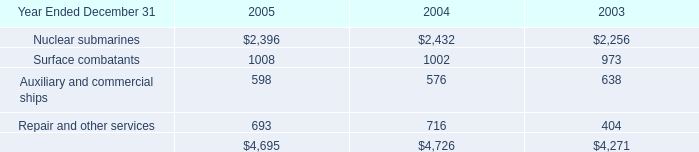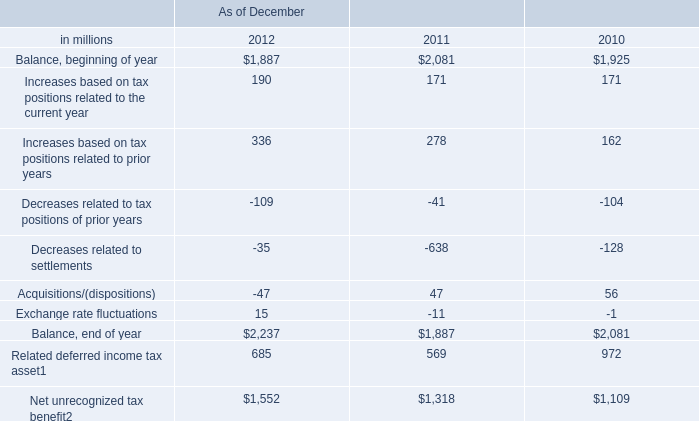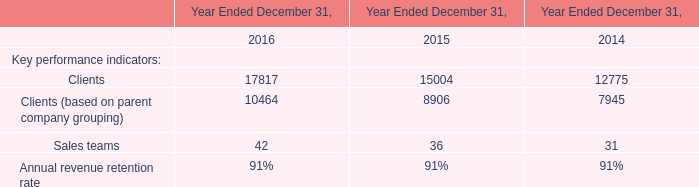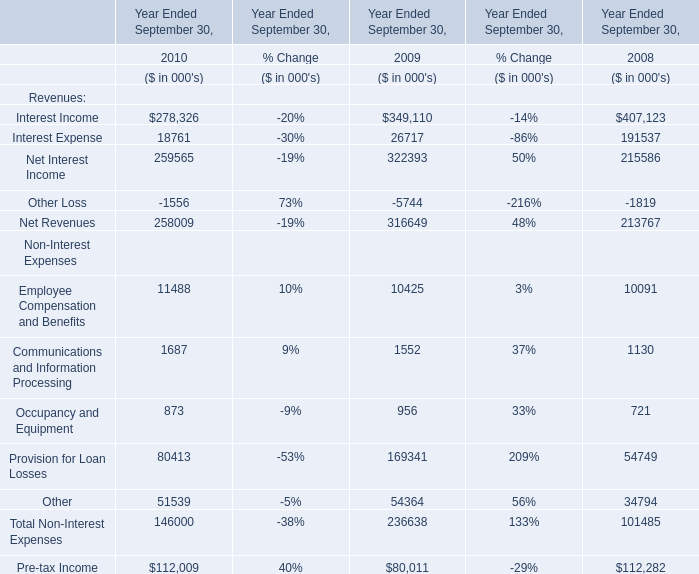What is the sum of Clients in 2016 and Interest Income in 2010 ? 
Computations: (17817 + 278326)
Answer: 296143.0. 